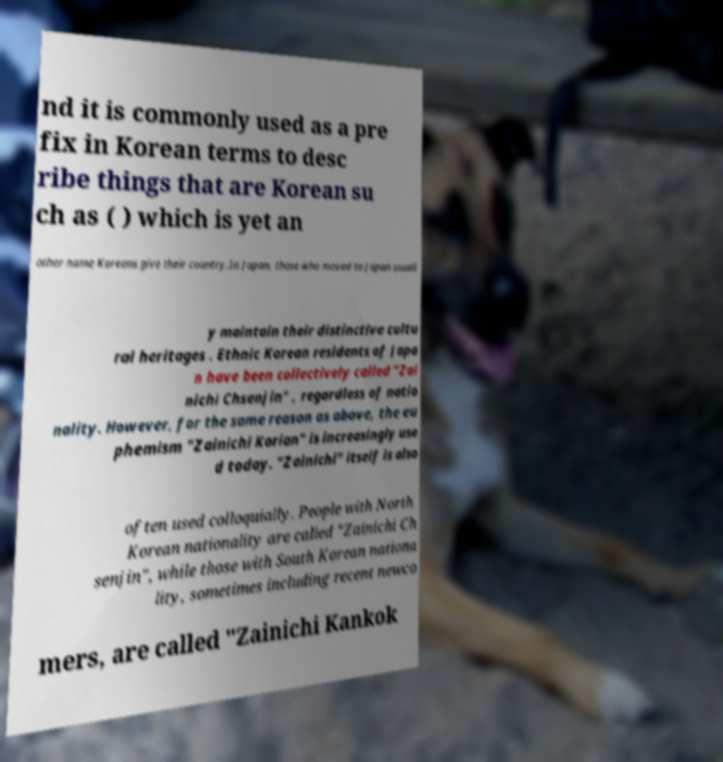Please identify and transcribe the text found in this image. nd it is commonly used as a pre fix in Korean terms to desc ribe things that are Korean su ch as ( ) which is yet an other name Koreans give their country.In Japan, those who moved to Japan usuall y maintain their distinctive cultu ral heritages . Ethnic Korean residents of Japa n have been collectively called "Zai nichi Chsenjin" , regardless of natio nality. However, for the same reason as above, the eu phemism "Zainichi Korian" is increasingly use d today. "Zainichi" itself is also often used colloquially. People with North Korean nationality are called "Zainichi Ch senjin", while those with South Korean nationa lity, sometimes including recent newco mers, are called "Zainichi Kankok 